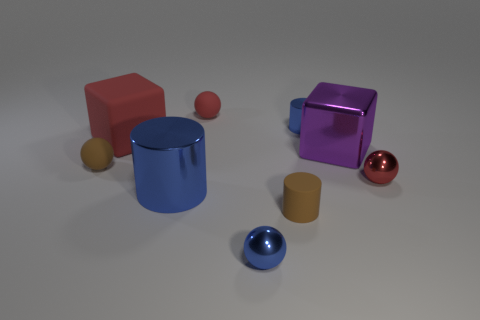Subtract all red balls. How many were subtracted if there are1red balls left? 1 Add 1 rubber cubes. How many objects exist? 10 Subtract all cylinders. How many objects are left? 6 Subtract 1 brown cylinders. How many objects are left? 8 Subtract all tiny shiny things. Subtract all large cylinders. How many objects are left? 5 Add 2 big rubber cubes. How many big rubber cubes are left? 3 Add 8 tiny rubber balls. How many tiny rubber balls exist? 10 